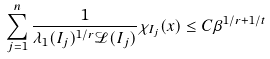Convert formula to latex. <formula><loc_0><loc_0><loc_500><loc_500>\sum _ { j = 1 } ^ { n } \frac { 1 } { \lambda _ { 1 } ( I _ { j } ) ^ { 1 / r } \mathcal { L } ( I _ { j } ) } \chi _ { I _ { j } } ( x ) \leq C { \beta ^ { 1 / r + 1 / t } }</formula> 